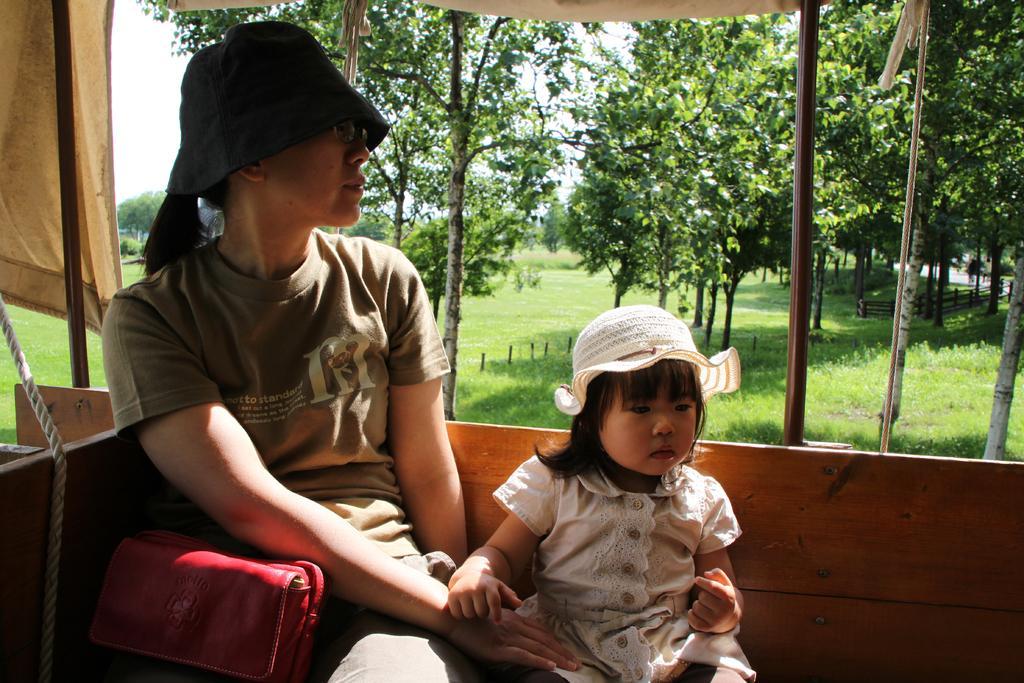Could you give a brief overview of what you see in this image? In this image there is a woman who is wearing the black cap and spectacles is sitting in the vehicle. Beside the woman there is a small kid. There is a red color bag beside the woman. In the background there are trees. On the ground there is grass. On the left side there is a rope and a curtain. 